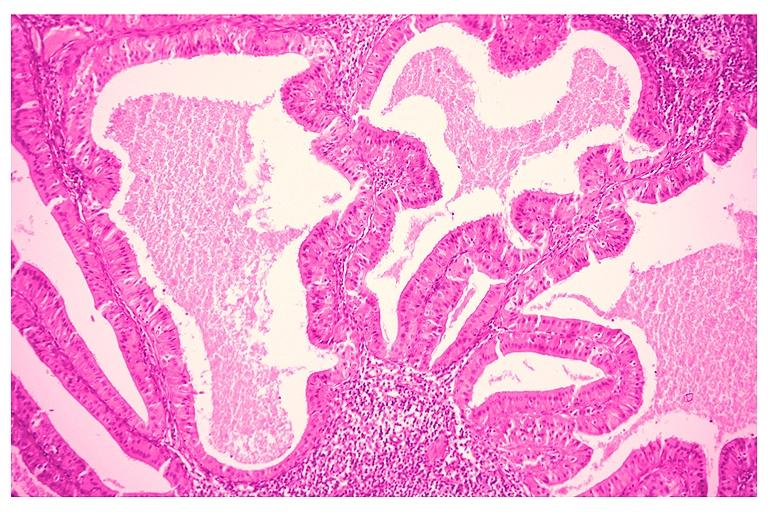s oral present?
Answer the question using a single word or phrase. Yes 